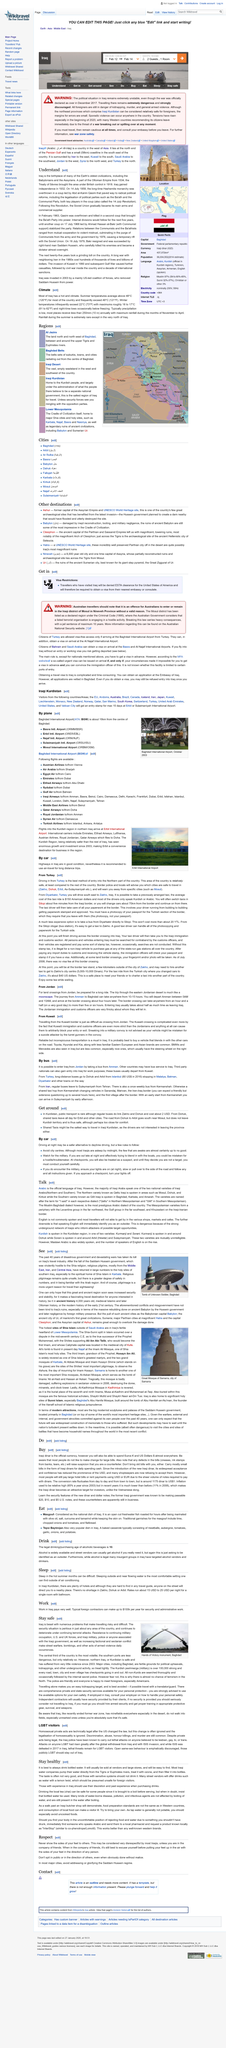Give some essential details in this illustration. The United States Department of State has issued a travel warning that specifically addresses LGBT visitors to Iraq, advising them to exercise extreme caution due to ongoing safety concerns. It is advisable for individuals who are publicly LGBT to avoid traveling to Iraq for their own safety. The U.S. and U.K. forces, along with Iraqi military, police, and any individuals affiliated with the Iraqi government, are responsible for the majority of armed violence in Iraq. Iraq was part of the Ottoman Empire from 1534 until its independence in 1932. In 2016, the cost of taking long distance buses from Dohuk and Arbil to Istanbul was approximately 80 US dollars. 